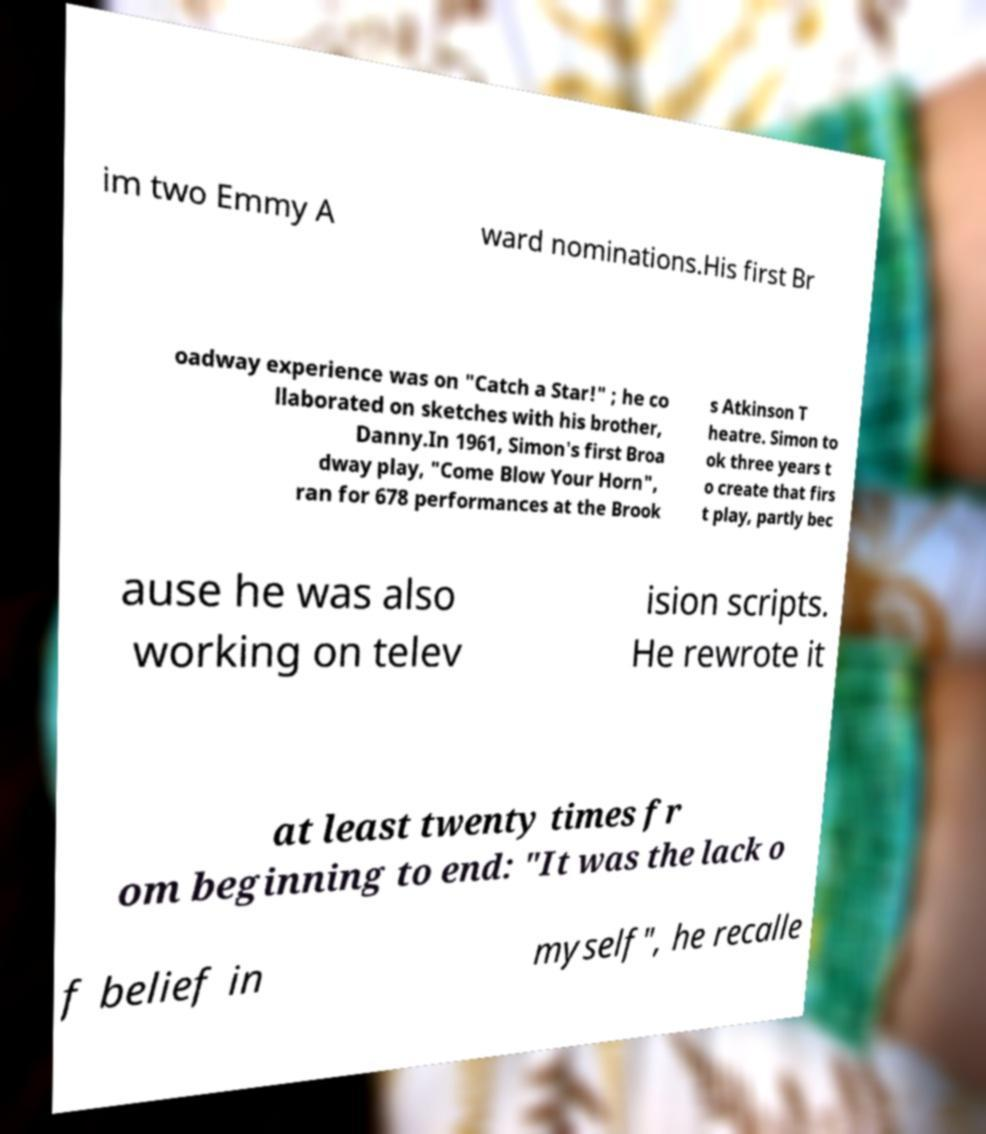Could you assist in decoding the text presented in this image and type it out clearly? im two Emmy A ward nominations.His first Br oadway experience was on "Catch a Star!" ; he co llaborated on sketches with his brother, Danny.In 1961, Simon's first Broa dway play, "Come Blow Your Horn", ran for 678 performances at the Brook s Atkinson T heatre. Simon to ok three years t o create that firs t play, partly bec ause he was also working on telev ision scripts. He rewrote it at least twenty times fr om beginning to end: "It was the lack o f belief in myself", he recalle 